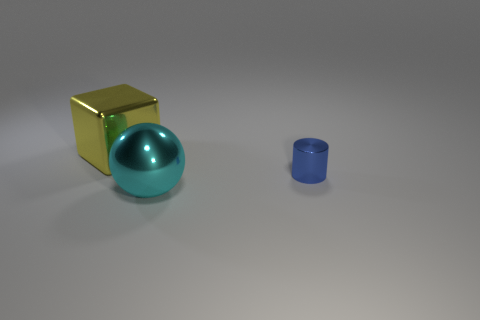There is a shiny object behind the metal object that is on the right side of the object in front of the tiny cylinder; how big is it?
Your response must be concise. Large. There is a metal thing in front of the blue object; what is its size?
Provide a short and direct response. Large. How many blue objects are either shiny cubes or shiny spheres?
Give a very brief answer. 0. Is the number of cyan metal spheres left of the yellow metallic block the same as the number of large yellow blocks to the right of the shiny sphere?
Provide a short and direct response. Yes. There is a yellow metallic block; is it the same size as the blue metal cylinder behind the cyan ball?
Your answer should be compact. No. Are there more metal things that are behind the cyan shiny object than large purple shiny blocks?
Make the answer very short. Yes. What number of other yellow objects are the same size as the yellow shiny object?
Your answer should be compact. 0. Do the metallic object behind the tiny metal thing and the thing that is in front of the small metal object have the same size?
Offer a terse response. Yes. Are there more blue metallic cylinders that are in front of the big yellow metal cube than cyan metallic objects that are on the left side of the cyan metal object?
Your answer should be compact. Yes. How many yellow metallic things are the same shape as the blue thing?
Provide a short and direct response. 0. 